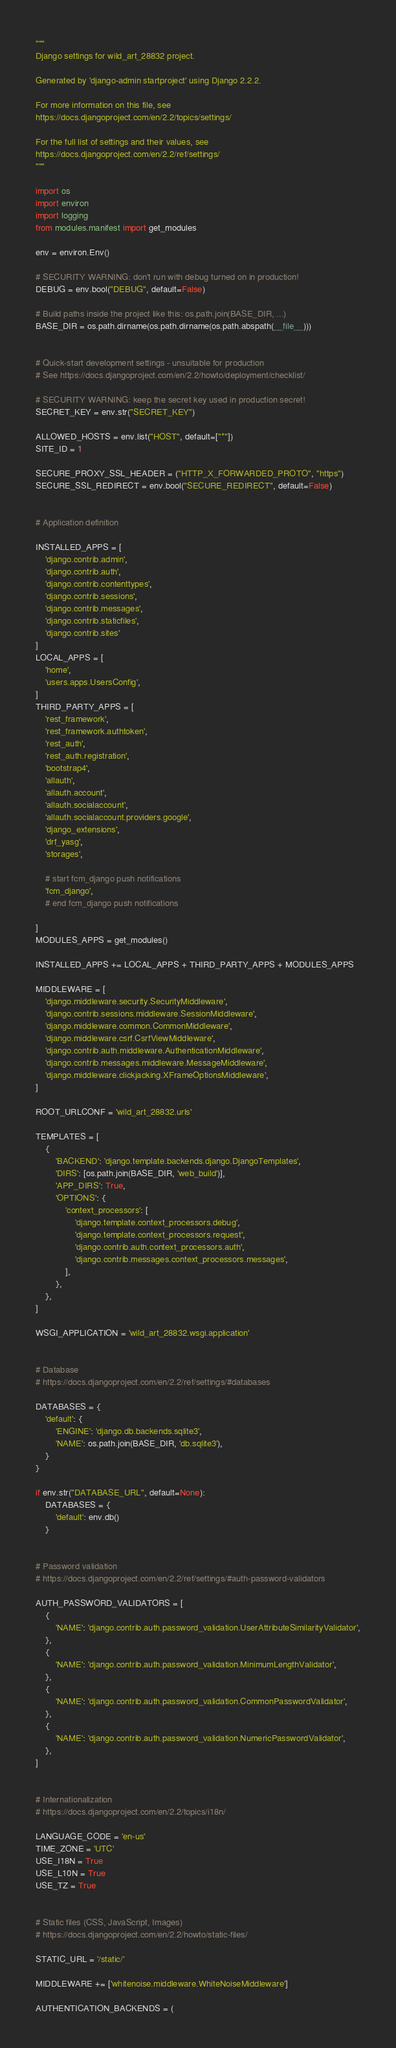Convert code to text. <code><loc_0><loc_0><loc_500><loc_500><_Python_>"""
Django settings for wild_art_28832 project.

Generated by 'django-admin startproject' using Django 2.2.2.

For more information on this file, see
https://docs.djangoproject.com/en/2.2/topics/settings/

For the full list of settings and their values, see
https://docs.djangoproject.com/en/2.2/ref/settings/
"""

import os
import environ
import logging
from modules.manifest import get_modules

env = environ.Env()

# SECURITY WARNING: don't run with debug turned on in production!
DEBUG = env.bool("DEBUG", default=False)

# Build paths inside the project like this: os.path.join(BASE_DIR, ...)
BASE_DIR = os.path.dirname(os.path.dirname(os.path.abspath(__file__)))


# Quick-start development settings - unsuitable for production
# See https://docs.djangoproject.com/en/2.2/howto/deployment/checklist/

# SECURITY WARNING: keep the secret key used in production secret!
SECRET_KEY = env.str("SECRET_KEY")

ALLOWED_HOSTS = env.list("HOST", default=["*"])
SITE_ID = 1

SECURE_PROXY_SSL_HEADER = ("HTTP_X_FORWARDED_PROTO", "https")
SECURE_SSL_REDIRECT = env.bool("SECURE_REDIRECT", default=False)


# Application definition

INSTALLED_APPS = [
    'django.contrib.admin',
    'django.contrib.auth',
    'django.contrib.contenttypes',
    'django.contrib.sessions',
    'django.contrib.messages',
    'django.contrib.staticfiles',
    'django.contrib.sites'
]
LOCAL_APPS = [
    'home',
    'users.apps.UsersConfig',
]
THIRD_PARTY_APPS = [
    'rest_framework',
    'rest_framework.authtoken',
    'rest_auth',
    'rest_auth.registration',
    'bootstrap4',
    'allauth',
    'allauth.account',
    'allauth.socialaccount',
    'allauth.socialaccount.providers.google',
    'django_extensions',
    'drf_yasg',
    'storages',

    # start fcm_django push notifications
    'fcm_django',
    # end fcm_django push notifications

]
MODULES_APPS = get_modules()

INSTALLED_APPS += LOCAL_APPS + THIRD_PARTY_APPS + MODULES_APPS

MIDDLEWARE = [
    'django.middleware.security.SecurityMiddleware',
    'django.contrib.sessions.middleware.SessionMiddleware',
    'django.middleware.common.CommonMiddleware',
    'django.middleware.csrf.CsrfViewMiddleware',
    'django.contrib.auth.middleware.AuthenticationMiddleware',
    'django.contrib.messages.middleware.MessageMiddleware',
    'django.middleware.clickjacking.XFrameOptionsMiddleware',
]

ROOT_URLCONF = 'wild_art_28832.urls'

TEMPLATES = [
    {
        'BACKEND': 'django.template.backends.django.DjangoTemplates',
        'DIRS': [os.path.join(BASE_DIR, 'web_build')],
        'APP_DIRS': True,
        'OPTIONS': {
            'context_processors': [
                'django.template.context_processors.debug',
                'django.template.context_processors.request',
                'django.contrib.auth.context_processors.auth',
                'django.contrib.messages.context_processors.messages',
            ],
        },
    },
]

WSGI_APPLICATION = 'wild_art_28832.wsgi.application'


# Database
# https://docs.djangoproject.com/en/2.2/ref/settings/#databases

DATABASES = {
    'default': {
        'ENGINE': 'django.db.backends.sqlite3',
        'NAME': os.path.join(BASE_DIR, 'db.sqlite3'),
    }
}

if env.str("DATABASE_URL", default=None):
    DATABASES = {
        'default': env.db()
    }


# Password validation
# https://docs.djangoproject.com/en/2.2/ref/settings/#auth-password-validators

AUTH_PASSWORD_VALIDATORS = [
    {
        'NAME': 'django.contrib.auth.password_validation.UserAttributeSimilarityValidator',
    },
    {
        'NAME': 'django.contrib.auth.password_validation.MinimumLengthValidator',
    },
    {
        'NAME': 'django.contrib.auth.password_validation.CommonPasswordValidator',
    },
    {
        'NAME': 'django.contrib.auth.password_validation.NumericPasswordValidator',
    },
]


# Internationalization
# https://docs.djangoproject.com/en/2.2/topics/i18n/

LANGUAGE_CODE = 'en-us'
TIME_ZONE = 'UTC'
USE_I18N = True
USE_L10N = True
USE_TZ = True


# Static files (CSS, JavaScript, Images)
# https://docs.djangoproject.com/en/2.2/howto/static-files/

STATIC_URL = '/static/'

MIDDLEWARE += ['whitenoise.middleware.WhiteNoiseMiddleware']

AUTHENTICATION_BACKENDS = (</code> 